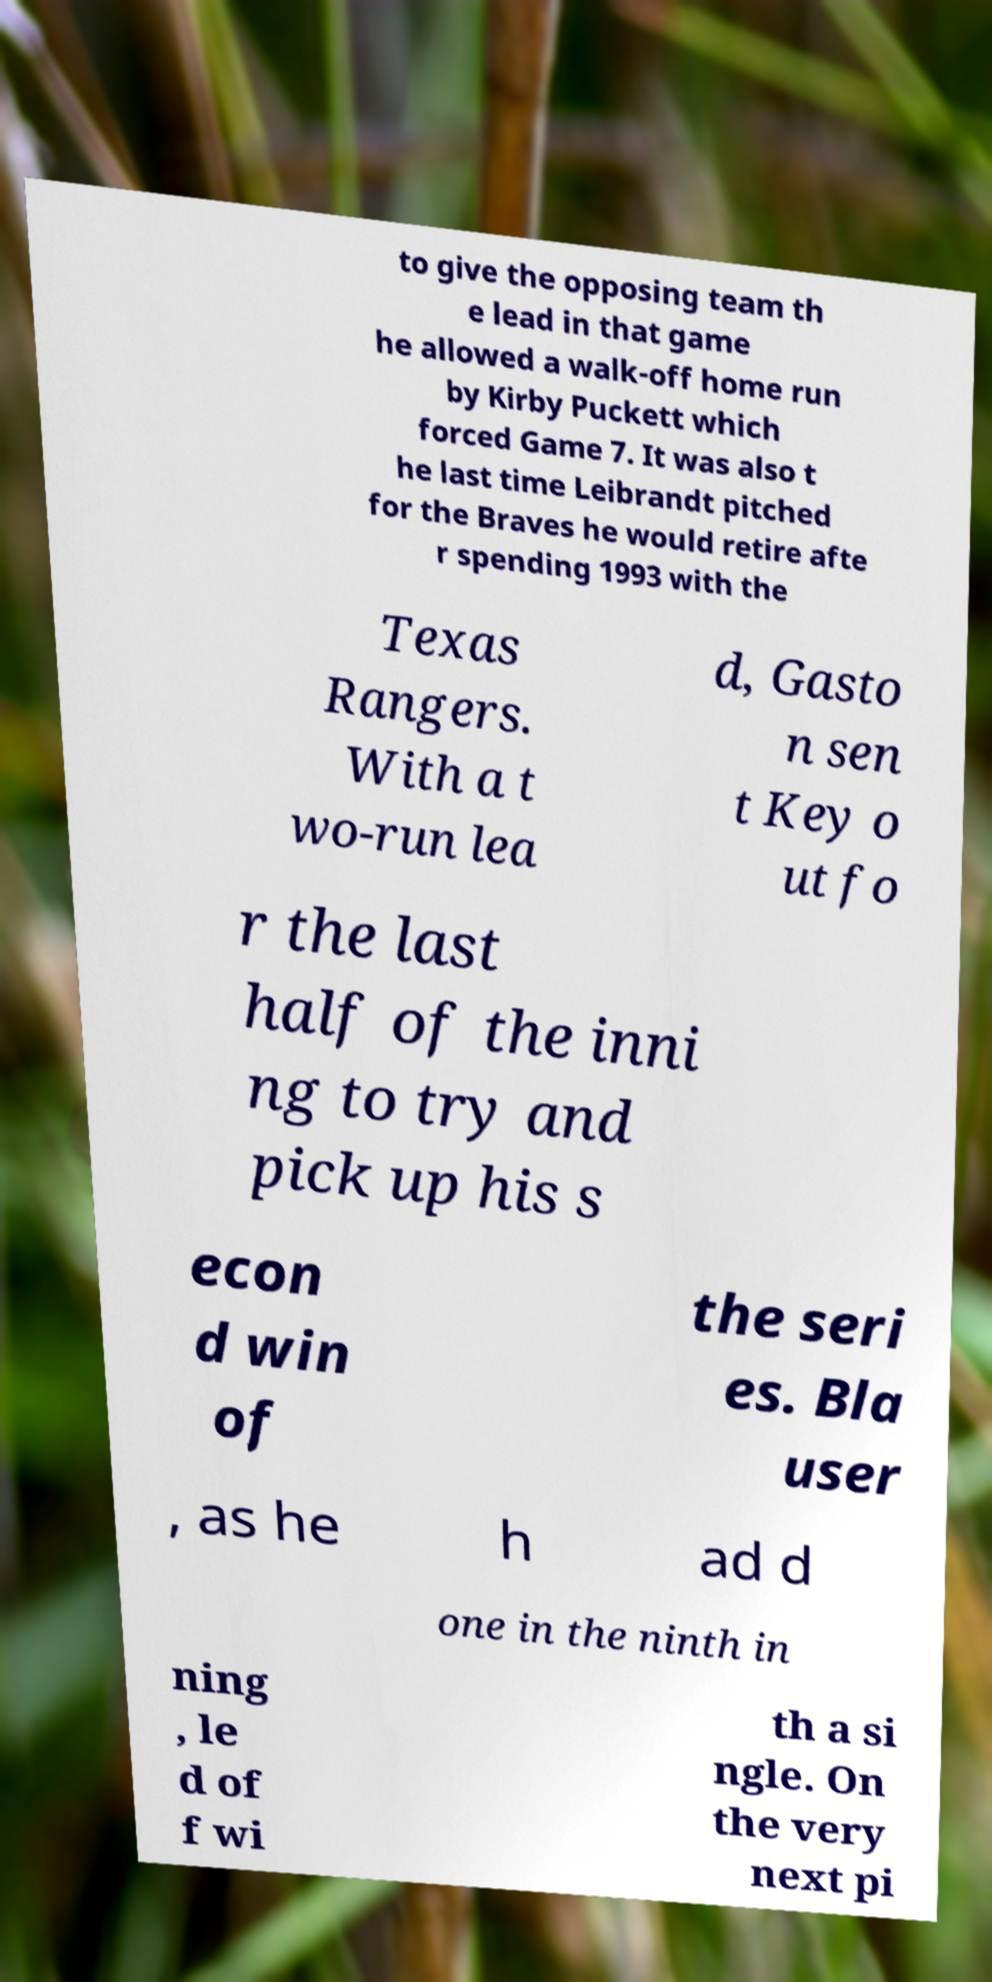For documentation purposes, I need the text within this image transcribed. Could you provide that? to give the opposing team th e lead in that game he allowed a walk-off home run by Kirby Puckett which forced Game 7. It was also t he last time Leibrandt pitched for the Braves he would retire afte r spending 1993 with the Texas Rangers. With a t wo-run lea d, Gasto n sen t Key o ut fo r the last half of the inni ng to try and pick up his s econ d win of the seri es. Bla user , as he h ad d one in the ninth in ning , le d of f wi th a si ngle. On the very next pi 